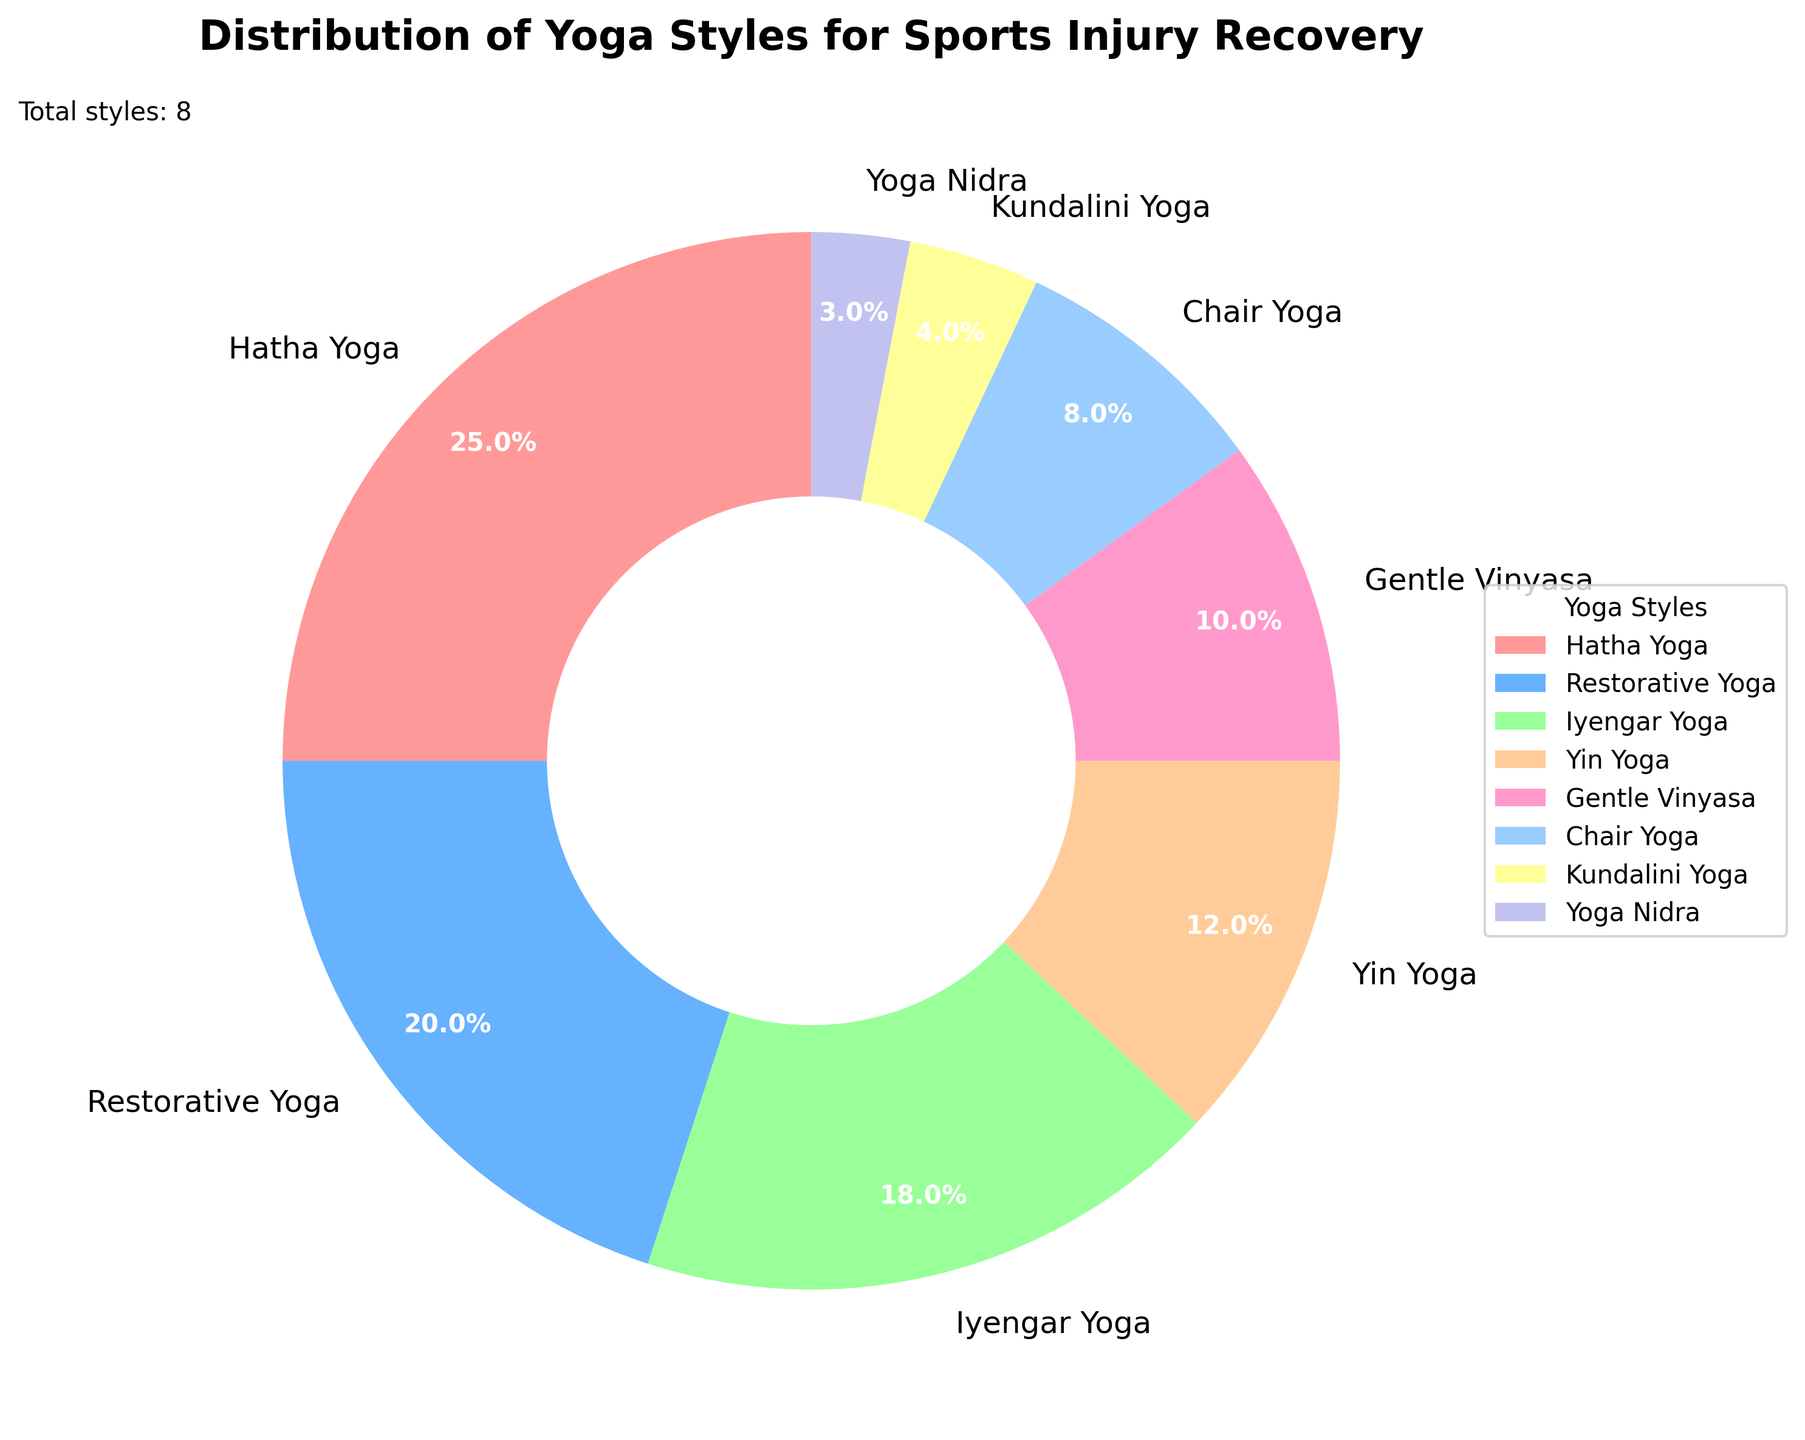What percentage of the distribution is covered by Hatha Yoga and Restorative Yoga combined? The percentage of the distribution covered by Hatha Yoga is 25%, and for Restorative Yoga, it is 20%. By summing these two percentages, we get 25 + 20 = 45%.
Answer: 45% Which yoga style has the smallest percentage in the distribution? By looking at the slices of the pie chart, we can identify that Yoga Nidra has the smallest percentage at 3%.
Answer: Yoga Nidra Which yoga style covers more percentage: Iyengar Yoga or Gentle Vinyasa? Iyengar Yoga covers 18% and Gentle Vinyasa covers 10%. Since 18% is greater than 10%, Iyengar Yoga covers more percentage.
Answer: Iyengar Yoga What is the visual color representing Chair Yoga in the pie chart? The pie chart has a legend showing colors for each yoga style. The color associated with Chair Yoga is the light blue color.
Answer: Light blue How many yoga styles cover 10% or less of the distribution? The styles that cover 10% or less are Gentle Vinyasa (10%), Chair Yoga (8%), Kundalini Yoga (4%), and Yoga Nidra (3%). There are four such styles.
Answer: 4 Which two yoga styles collectively cover more than Restorative Yoga's percentage? Restorative Yoga covers 20%. The percentages for Yin Yoga is 12% and Chair Yoga is 8%. By adding them, we get 12 + 8 = 20%, which is equal. Therefore, more than Restorative Yoga can be achieved by Gentle Vinyasa and Chair Yoga: 10 + 8 = 18%. Hence, collectively more than Restorative Yogacan also be, Hatha Yoga and any style starting lower than Restorative will also meet, any 25+% with non-Hatha Yoga style will do. Comparing Kundalini Yoga and Yoga Nidra collectively also beats Restorative.
Answer: Hatha + any other Yoga Of the three yoga styles - Yin Yoga, Chair Yoga, and Gentle Vinyasa, which one has the highest representation? Yin Yoga has a percentage coverage of 12%, Chair Yoga has 8%, and Gentle Vinyasa has 10%. Therefore, Yin Yoga has the highest representation among the three.
Answer: Yin Yoga Is there any yoga style that holds exactly the same percentage as another style? The pie chart shows that all yoga styles have different percentages. No two yoga styles have the same percentage.
Answer: No How does the aggregate percentage of Kundalini Yoga and Yoga Nidra compare to Iyengar Yoga? Kundalini Yoga covers 4% and Yoga Nidra covers 3%. Their aggregate is 4 + 3 = 7%. Iyengar Yoga covers 18%. Since 7% is less than 18%, the aggregate is lower.
Answer: Less 